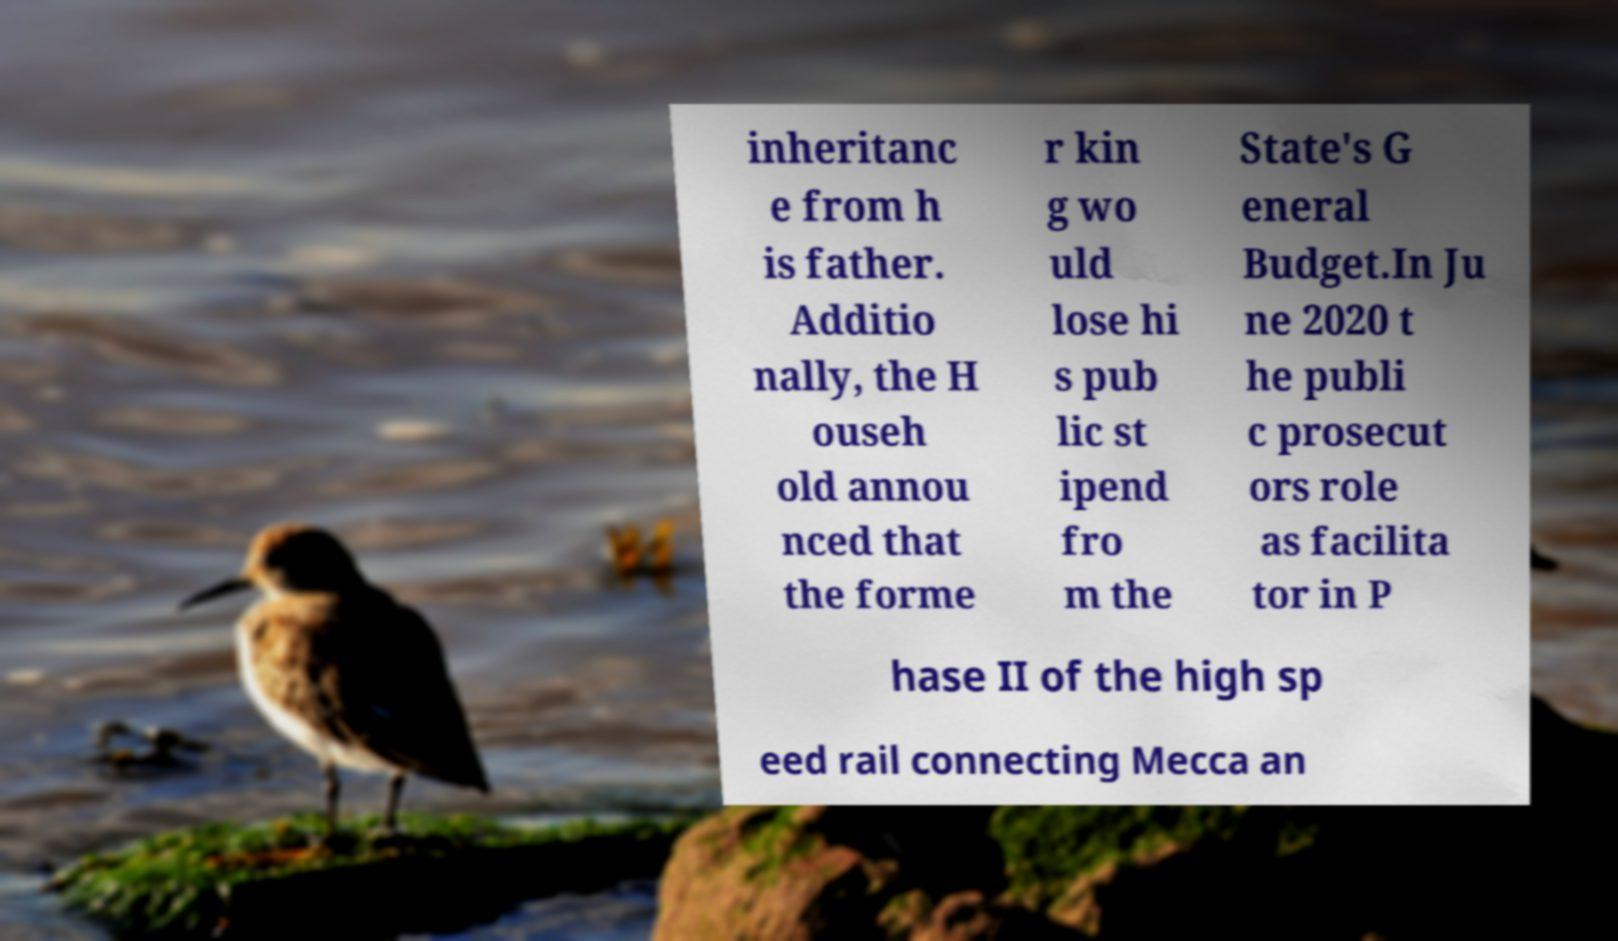There's text embedded in this image that I need extracted. Can you transcribe it verbatim? inheritanc e from h is father. Additio nally, the H ouseh old annou nced that the forme r kin g wo uld lose hi s pub lic st ipend fro m the State's G eneral Budget.In Ju ne 2020 t he publi c prosecut ors role as facilita tor in P hase II of the high sp eed rail connecting Mecca an 